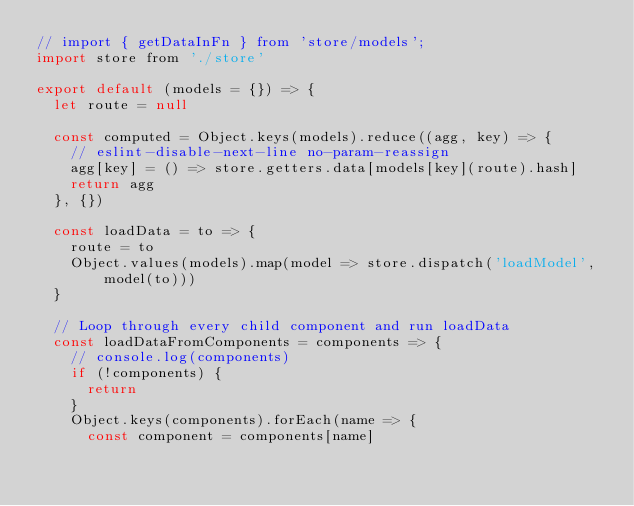Convert code to text. <code><loc_0><loc_0><loc_500><loc_500><_JavaScript_>// import { getDataInFn } from 'store/models';
import store from './store'

export default (models = {}) => {
  let route = null

  const computed = Object.keys(models).reduce((agg, key) => {
    // eslint-disable-next-line no-param-reassign
    agg[key] = () => store.getters.data[models[key](route).hash]
    return agg
  }, {})

  const loadData = to => {
    route = to
    Object.values(models).map(model => store.dispatch('loadModel', model(to)))
  }

  // Loop through every child component and run loadData
  const loadDataFromComponents = components => {
    // console.log(components)
    if (!components) {
      return
    }
    Object.keys(components).forEach(name => {
      const component = components[name]</code> 